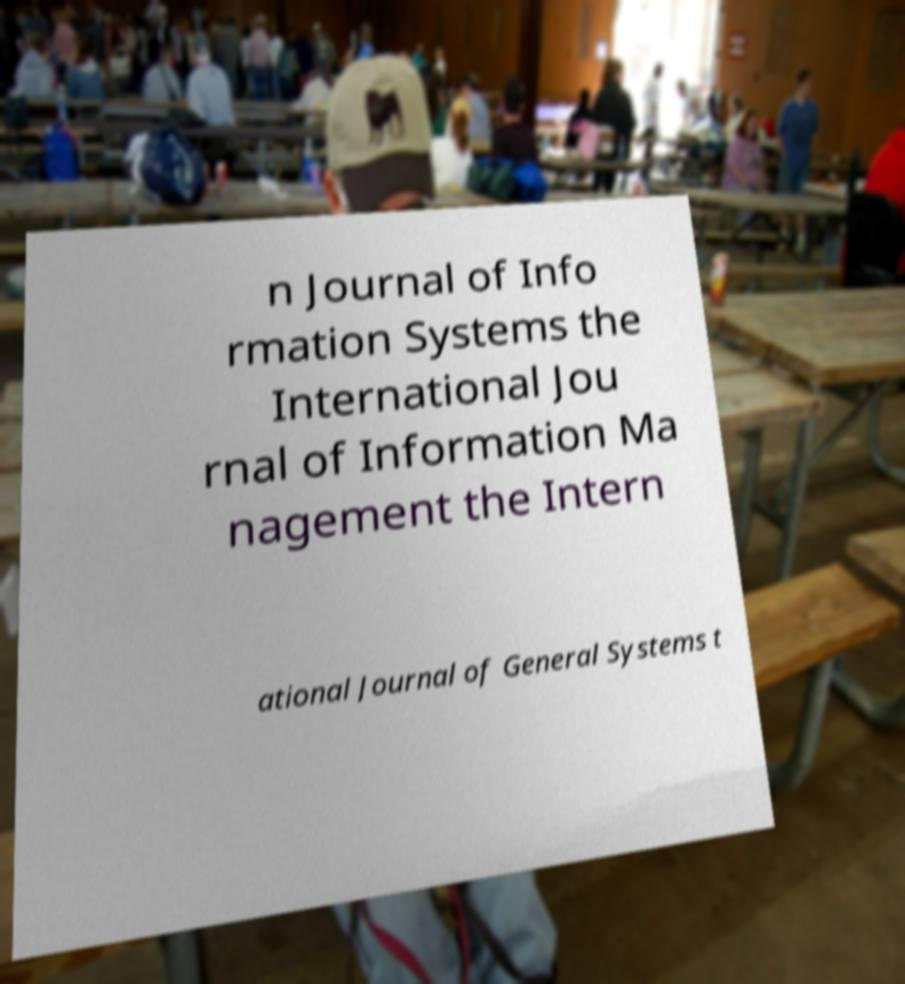Please identify and transcribe the text found in this image. n Journal of Info rmation Systems the International Jou rnal of Information Ma nagement the Intern ational Journal of General Systems t 